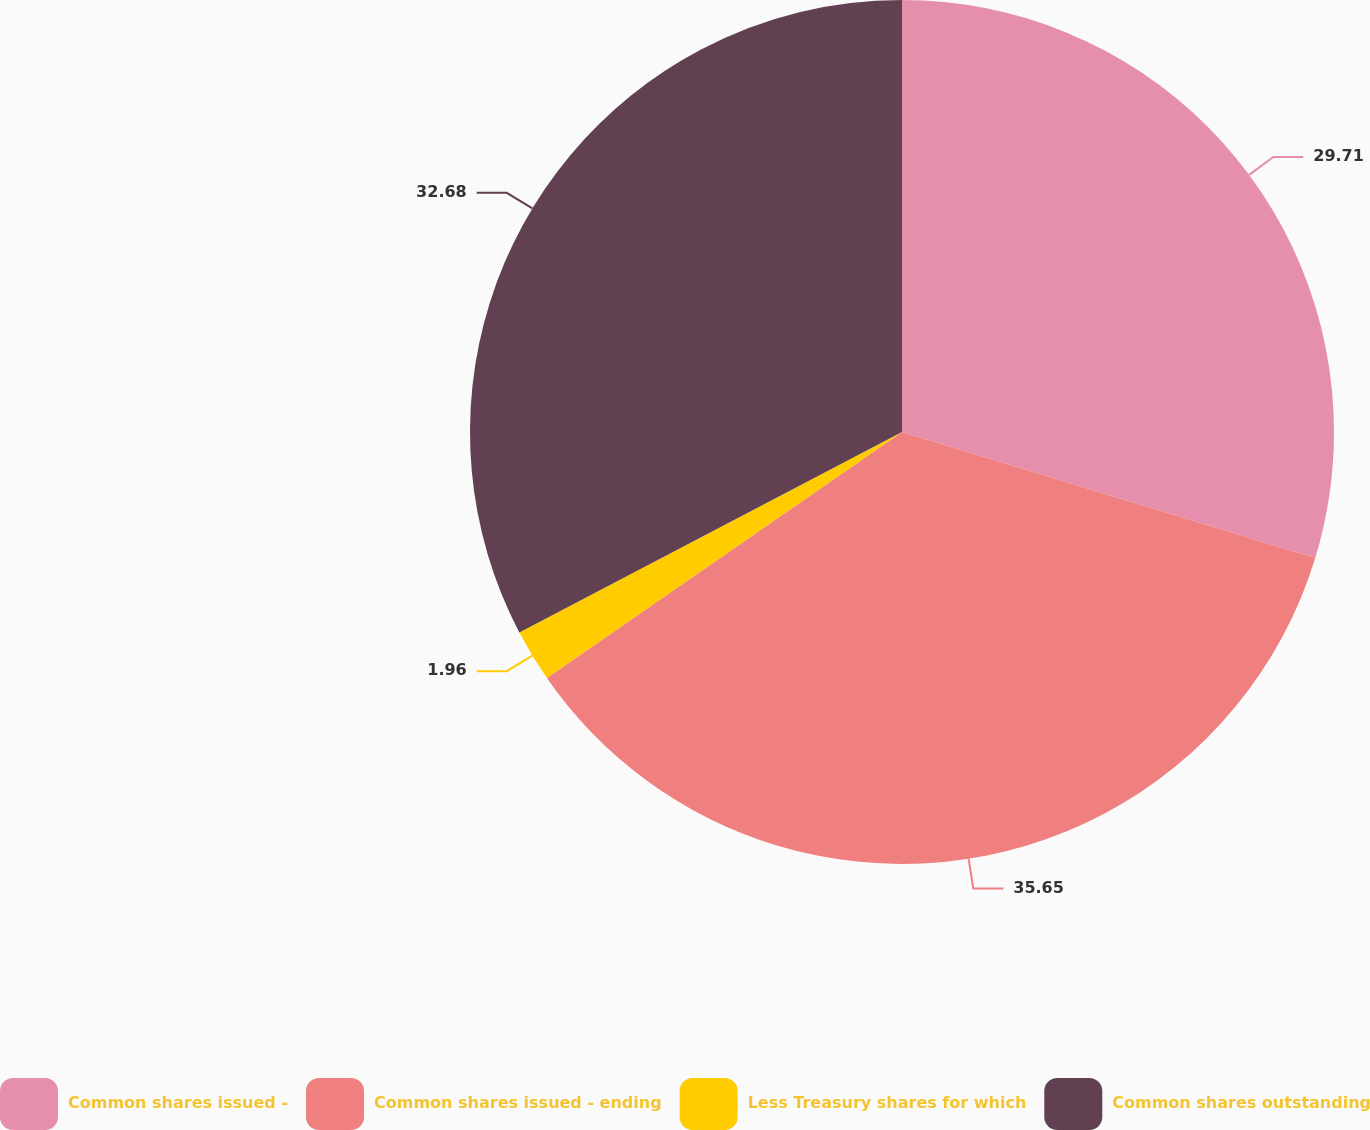<chart> <loc_0><loc_0><loc_500><loc_500><pie_chart><fcel>Common shares issued -<fcel>Common shares issued - ending<fcel>Less Treasury shares for which<fcel>Common shares outstanding<nl><fcel>29.71%<fcel>35.65%<fcel>1.96%<fcel>32.68%<nl></chart> 